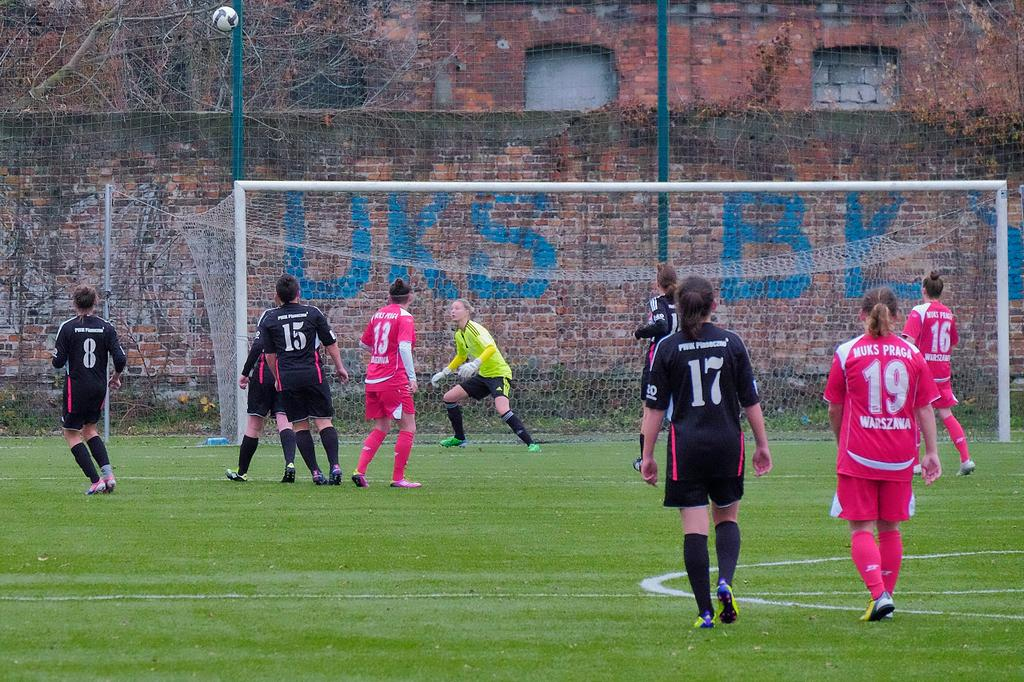<image>
Relay a brief, clear account of the picture shown. some men playing football, one of whom has a number 17 on his shirt 